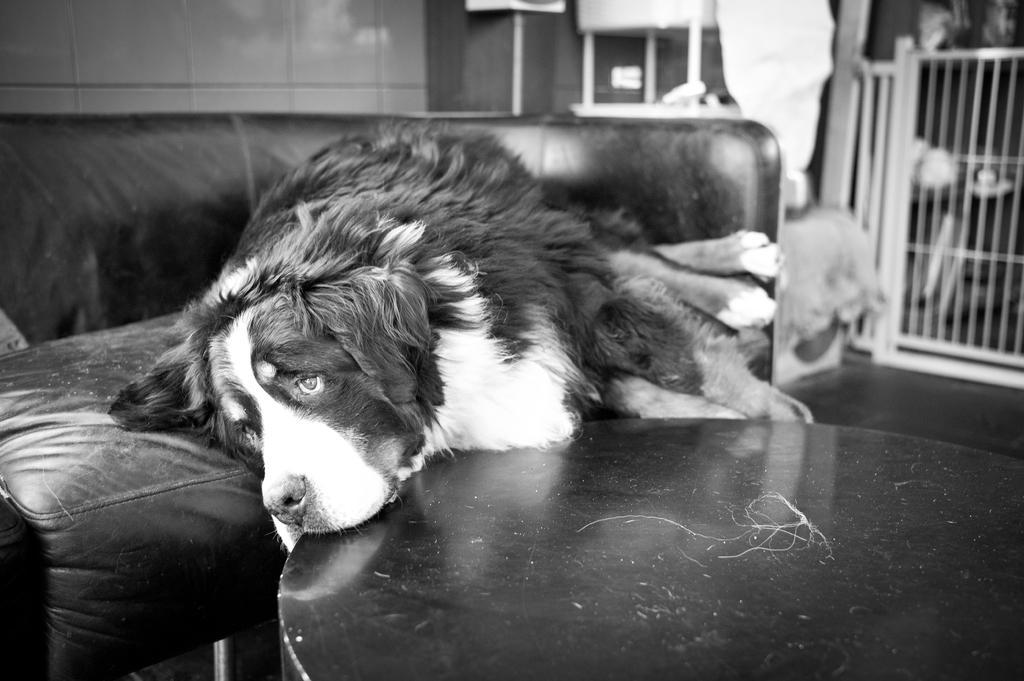Can you describe this image briefly? This is a black and white pic. Here we can see a dog lying on the sofa and placed its head on the table. In the background we can see a wall,fence and some other items. 